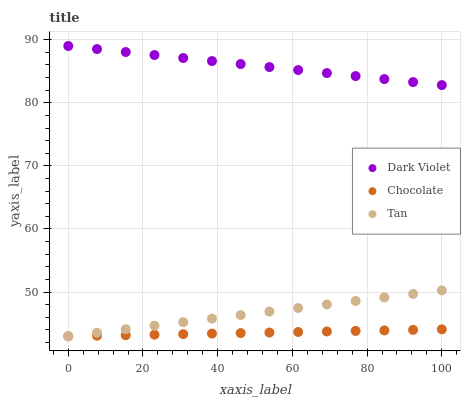Does Chocolate have the minimum area under the curve?
Answer yes or no. Yes. Does Dark Violet have the maximum area under the curve?
Answer yes or no. Yes. Does Dark Violet have the minimum area under the curve?
Answer yes or no. No. Does Chocolate have the maximum area under the curve?
Answer yes or no. No. Is Tan the smoothest?
Answer yes or no. Yes. Is Dark Violet the roughest?
Answer yes or no. Yes. Is Chocolate the smoothest?
Answer yes or no. No. Is Chocolate the roughest?
Answer yes or no. No. Does Tan have the lowest value?
Answer yes or no. Yes. Does Dark Violet have the lowest value?
Answer yes or no. No. Does Dark Violet have the highest value?
Answer yes or no. Yes. Does Chocolate have the highest value?
Answer yes or no. No. Is Chocolate less than Dark Violet?
Answer yes or no. Yes. Is Dark Violet greater than Chocolate?
Answer yes or no. Yes. Does Chocolate intersect Tan?
Answer yes or no. Yes. Is Chocolate less than Tan?
Answer yes or no. No. Is Chocolate greater than Tan?
Answer yes or no. No. Does Chocolate intersect Dark Violet?
Answer yes or no. No. 